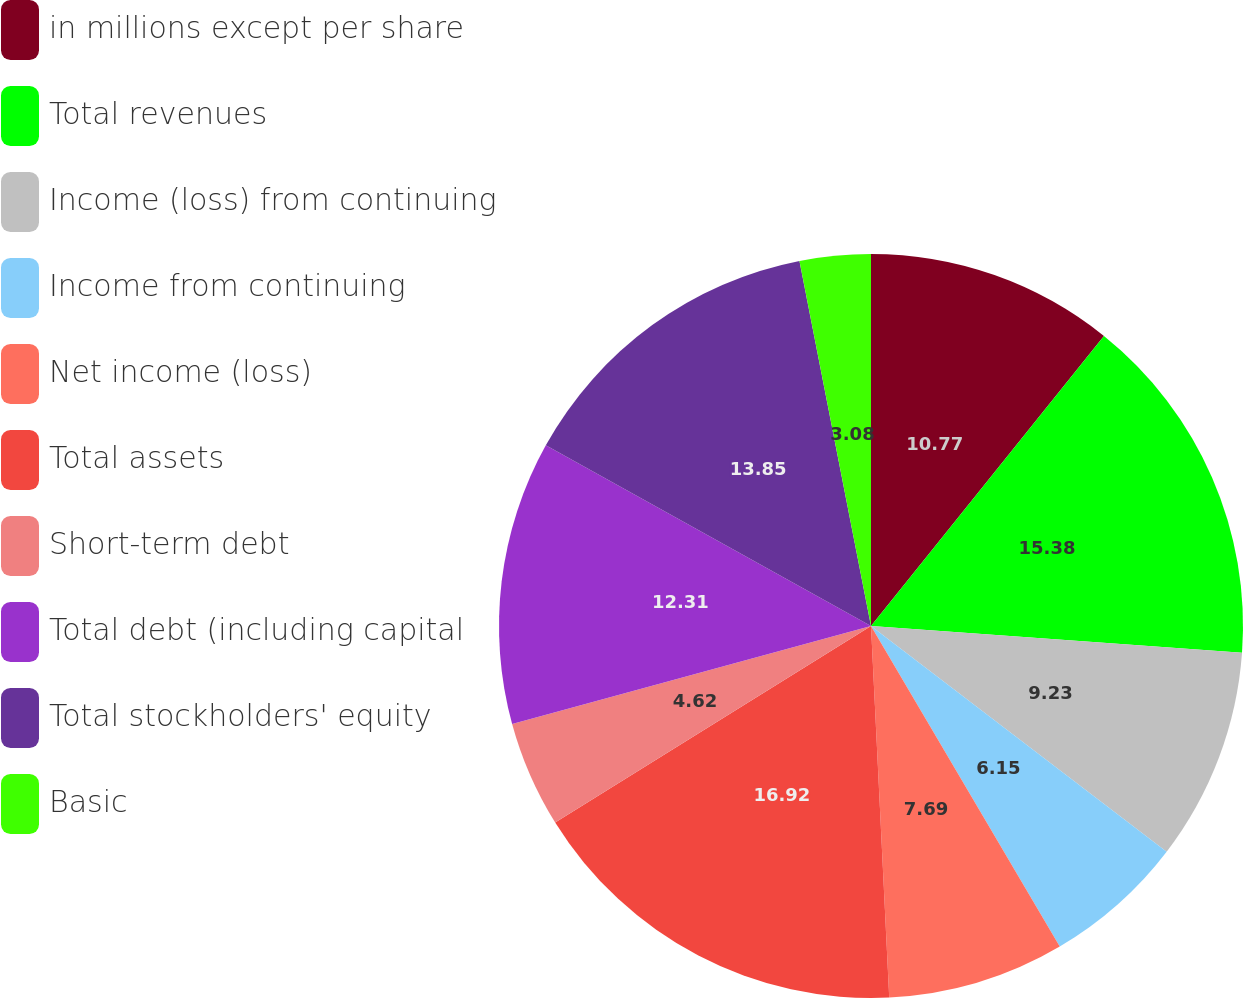<chart> <loc_0><loc_0><loc_500><loc_500><pie_chart><fcel>in millions except per share<fcel>Total revenues<fcel>Income (loss) from continuing<fcel>Income from continuing<fcel>Net income (loss)<fcel>Total assets<fcel>Short-term debt<fcel>Total debt (including capital<fcel>Total stockholders' equity<fcel>Basic<nl><fcel>10.77%<fcel>15.38%<fcel>9.23%<fcel>6.15%<fcel>7.69%<fcel>16.92%<fcel>4.62%<fcel>12.31%<fcel>13.85%<fcel>3.08%<nl></chart> 